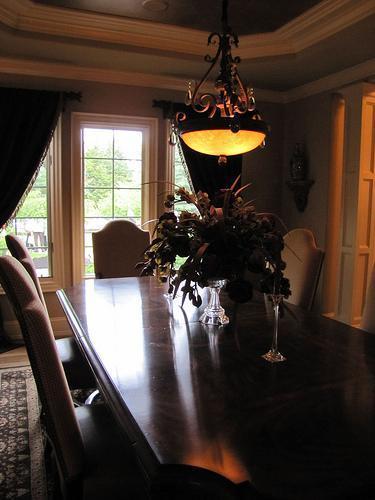How many lights are there?
Give a very brief answer. 1. 